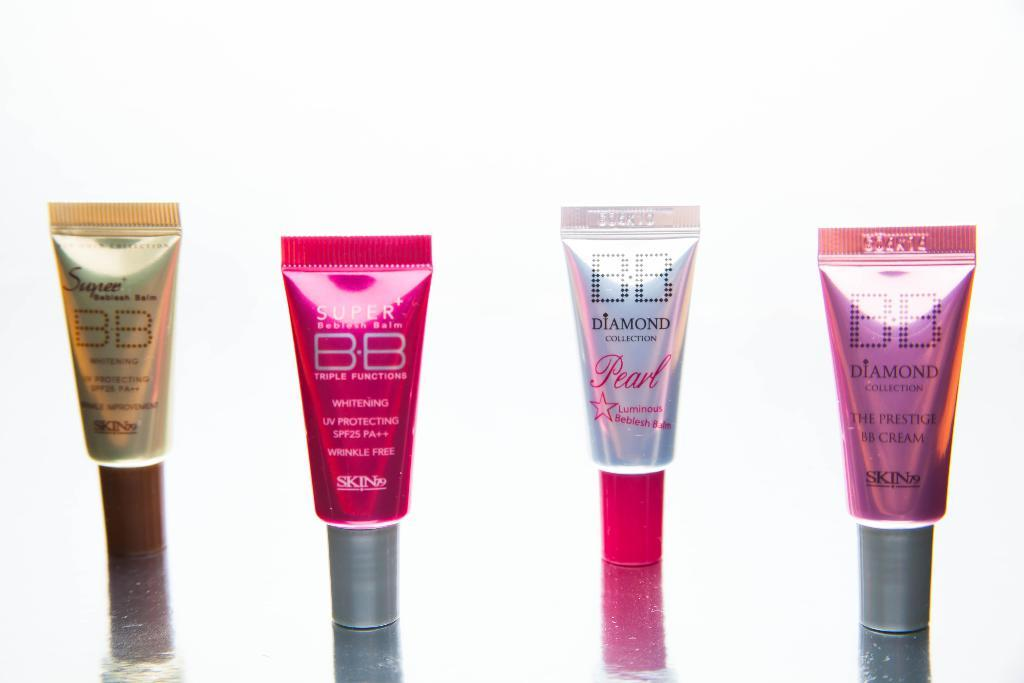<image>
Create a compact narrative representing the image presented. Four different brands of skin BB cream sitting on the table. 